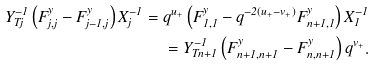<formula> <loc_0><loc_0><loc_500><loc_500>Y _ { T j } ^ { - 1 } \left ( F ^ { y } _ { j , j } - F ^ { y } _ { j - 1 , j } \right ) X _ { j } ^ { - 1 } = q ^ { u _ { + } } \left ( F ^ { y } _ { 1 , 1 } - q ^ { - 2 ( u _ { + } - v _ { + } ) } F ^ { y } _ { n + 1 , 1 } \right ) X _ { 1 } ^ { - 1 } \\ = Y _ { T n + 1 } ^ { - 1 } \left ( F ^ { y } _ { n + 1 , n + 1 } - F ^ { y } _ { n , n + 1 } \right ) q ^ { v _ { + } } .</formula> 